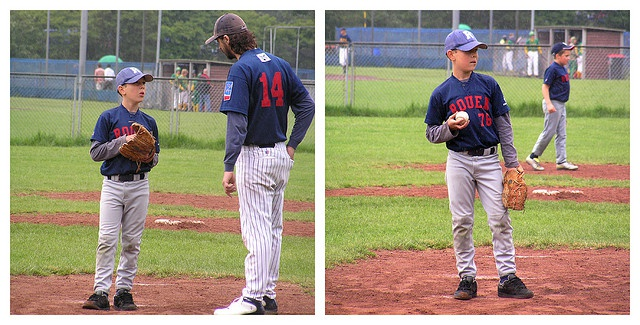Describe the objects in this image and their specific colors. I can see people in white, lavender, black, gray, and navy tones, people in white, black, darkgray, lavender, and navy tones, people in white, darkgray, black, lavender, and gray tones, people in white, darkgray, navy, gray, and lavender tones, and baseball glove in white, brown, tan, and salmon tones in this image. 